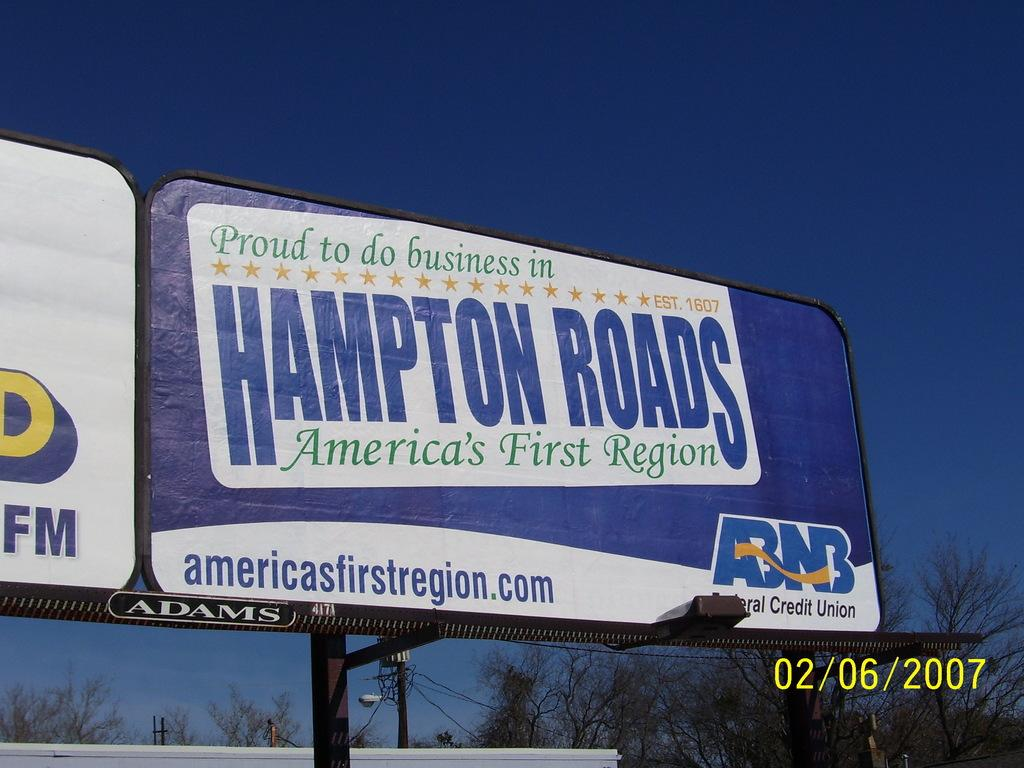<image>
Describe the image concisely. A billboard featuring Hampton Roads, America's First Region. 